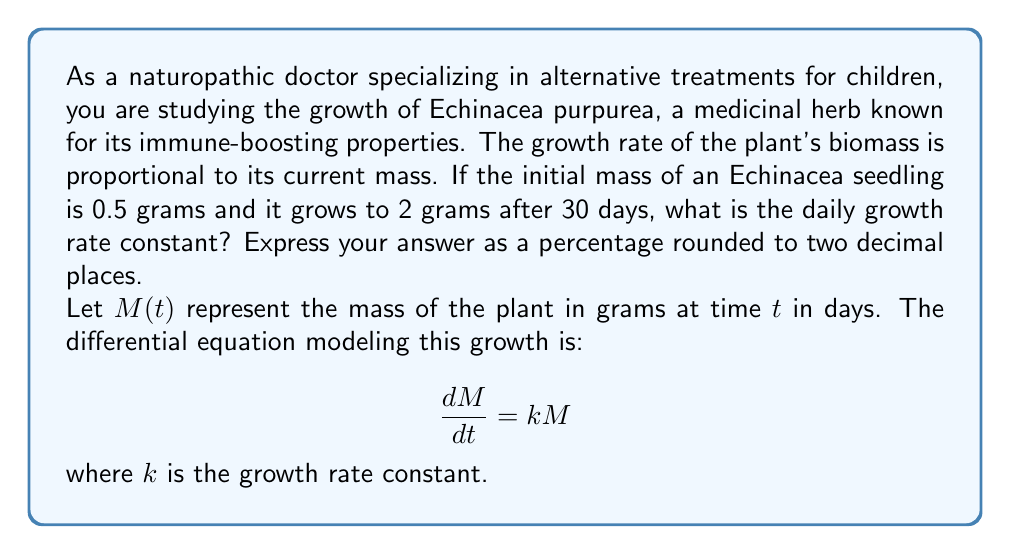Show me your answer to this math problem. To solve this problem, we'll follow these steps:

1) The given differential equation $\frac{dM}{dt} = kM$ is a separable equation. We can solve it as follows:

   $$\frac{dM}{M} = k\,dt$$

2) Integrating both sides:

   $$\int \frac{dM}{M} = \int k\,dt$$
   $$\ln|M| = kt + C$$

3) Taking the exponential of both sides:

   $$M = e^{kt + C} = e^C \cdot e^{kt} = M_0 \cdot e^{kt}$$

   where $M_0 = e^C$ is the initial mass.

4) We're given that $M_0 = 0.5$ grams and after 30 days, $M(30) = 2$ grams. Let's substitute these values:

   $$2 = 0.5 \cdot e^{30k}$$

5) Dividing both sides by 0.5:

   $$4 = e^{30k}$$

6) Taking the natural logarithm of both sides:

   $$\ln(4) = 30k$$

7) Solving for $k$:

   $$k = \frac{\ln(4)}{30} \approx 0.0462$$

8) To express this as a daily percentage growth rate, we multiply by 100:

   $$\text{Daily growth rate} = 0.0462 \times 100 \approx 4.62\%$$
Answer: 4.62% 